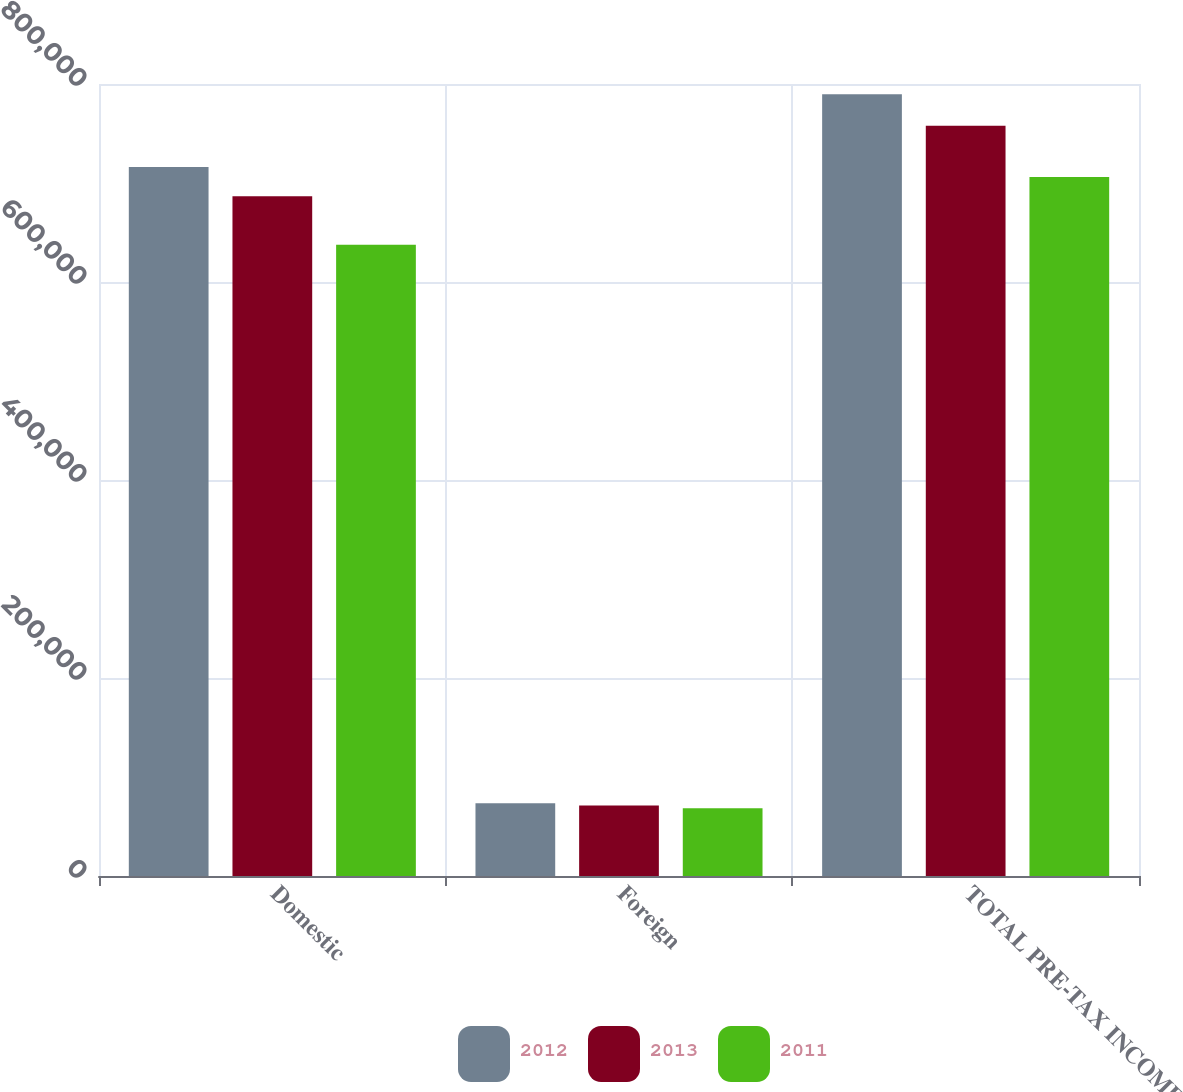<chart> <loc_0><loc_0><loc_500><loc_500><stacked_bar_chart><ecel><fcel>Domestic<fcel>Foreign<fcel>TOTAL PRE-TAX INCOME<nl><fcel>2012<fcel>716172<fcel>73527<fcel>789699<nl><fcel>2013<fcel>686571<fcel>71180<fcel>757751<nl><fcel>2011<fcel>637708<fcel>68419<fcel>706127<nl></chart> 